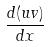<formula> <loc_0><loc_0><loc_500><loc_500>\frac { d ( u v ) } { d x }</formula> 